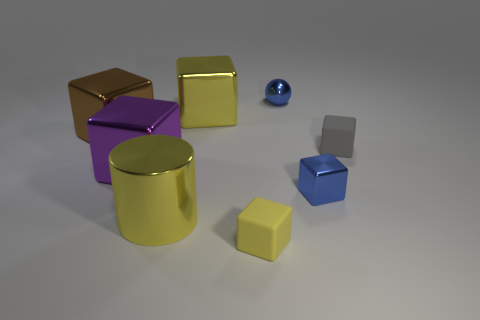Are the small yellow cube and the blue thing that is behind the tiny gray matte thing made of the same material?
Provide a short and direct response. No. What is the size of the gray thing that is the same shape as the purple metal thing?
Give a very brief answer. Small. What is the material of the small blue block?
Provide a succinct answer. Metal. What material is the yellow cube that is to the left of the yellow cube that is in front of the yellow block that is behind the yellow shiny cylinder?
Keep it short and to the point. Metal. There is a block to the right of the small shiny block; does it have the same size as the cube behind the brown metallic block?
Your answer should be compact. No. How many other objects are there of the same material as the large cylinder?
Provide a succinct answer. 5. How many matte objects are either brown blocks or tiny red cylinders?
Keep it short and to the point. 0. Are there fewer big brown metallic objects than blue cylinders?
Your answer should be very brief. No. There is a brown metal block; does it have the same size as the blue shiny object on the right side of the blue ball?
Ensure brevity in your answer.  No. Is there anything else that has the same shape as the big brown shiny object?
Provide a short and direct response. Yes. 